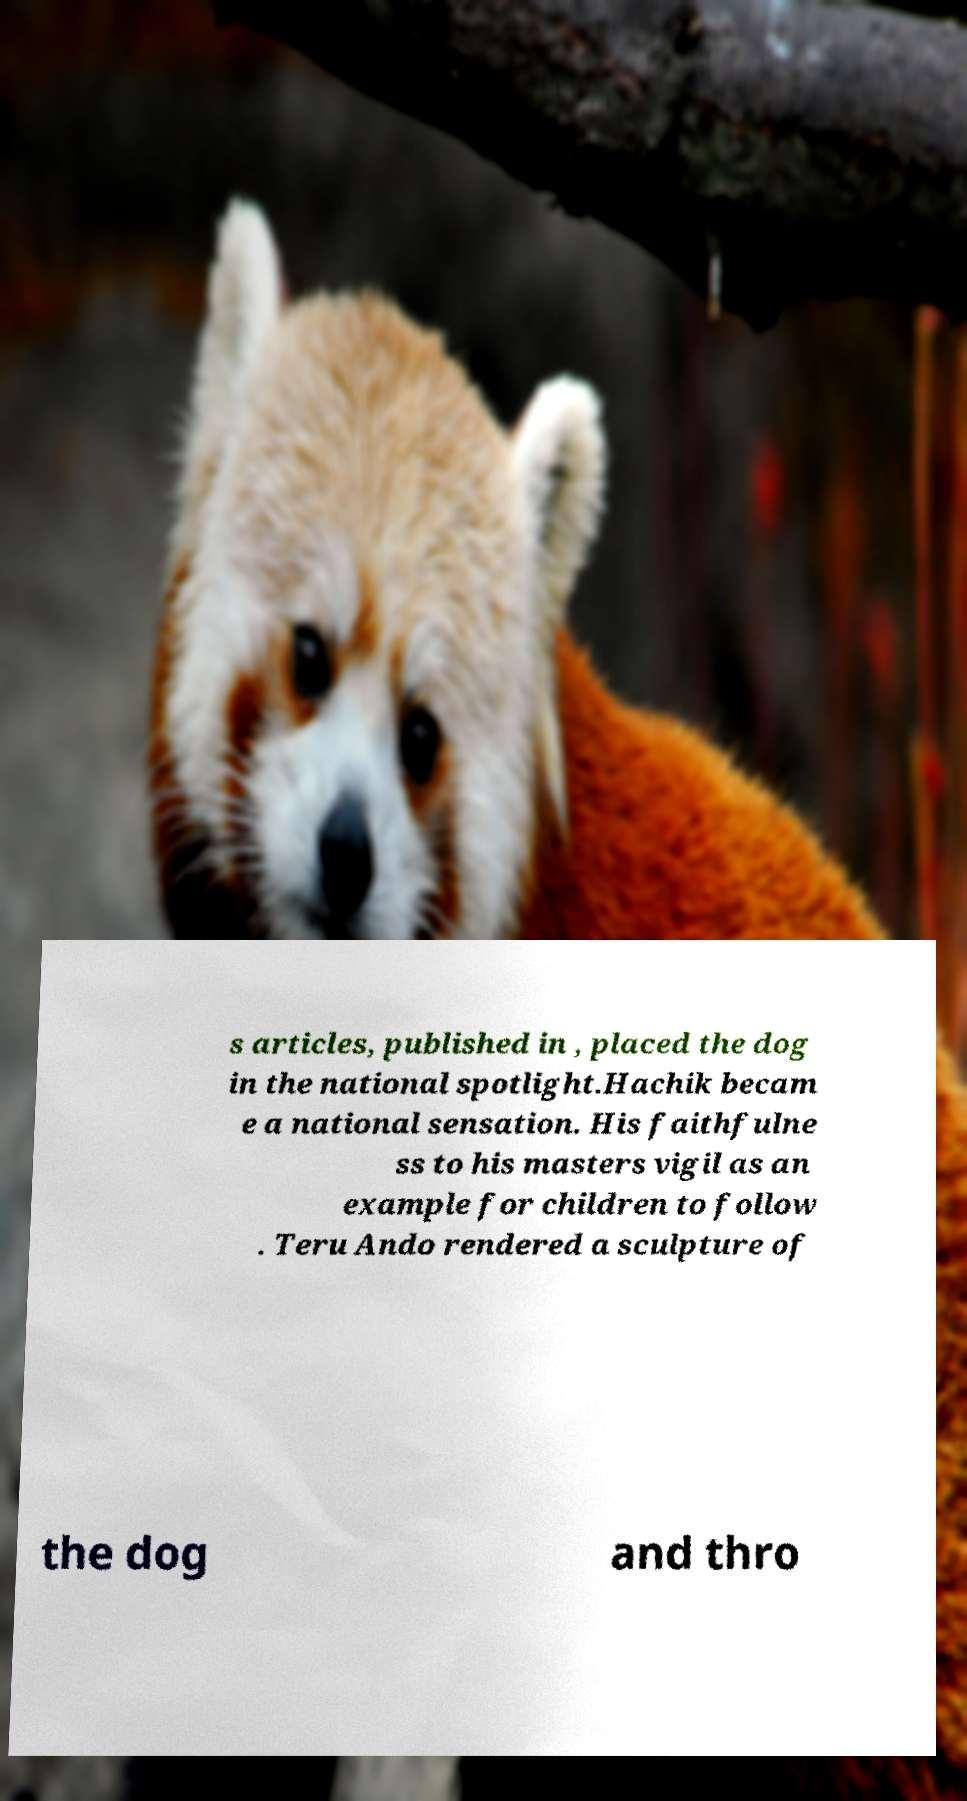For documentation purposes, I need the text within this image transcribed. Could you provide that? s articles, published in , placed the dog in the national spotlight.Hachik becam e a national sensation. His faithfulne ss to his masters vigil as an example for children to follow . Teru Ando rendered a sculpture of the dog and thro 